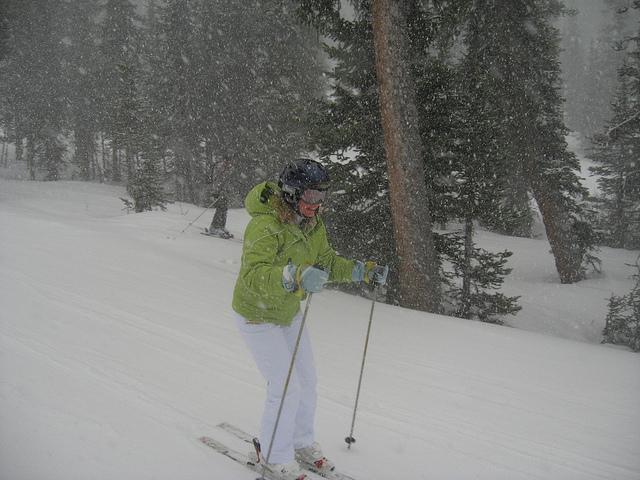What color is the coat the woman is wearing?
Write a very short answer. Green. What are the weather conditions?
Give a very brief answer. Snowy. How easy is it to drive in these conditions?
Answer briefly. Not easy. 